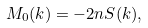<formula> <loc_0><loc_0><loc_500><loc_500>M _ { 0 } ( k ) = - 2 n S ( k ) ,</formula> 